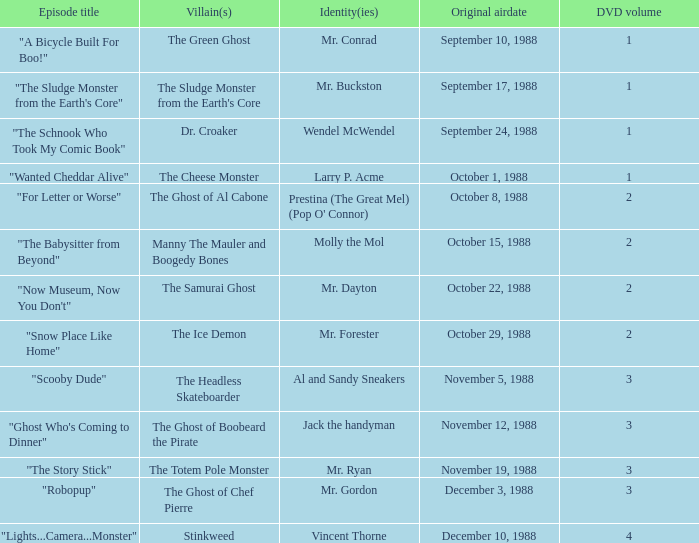Name the episode that aired october 8, 1988 "For Letter or Worse". 